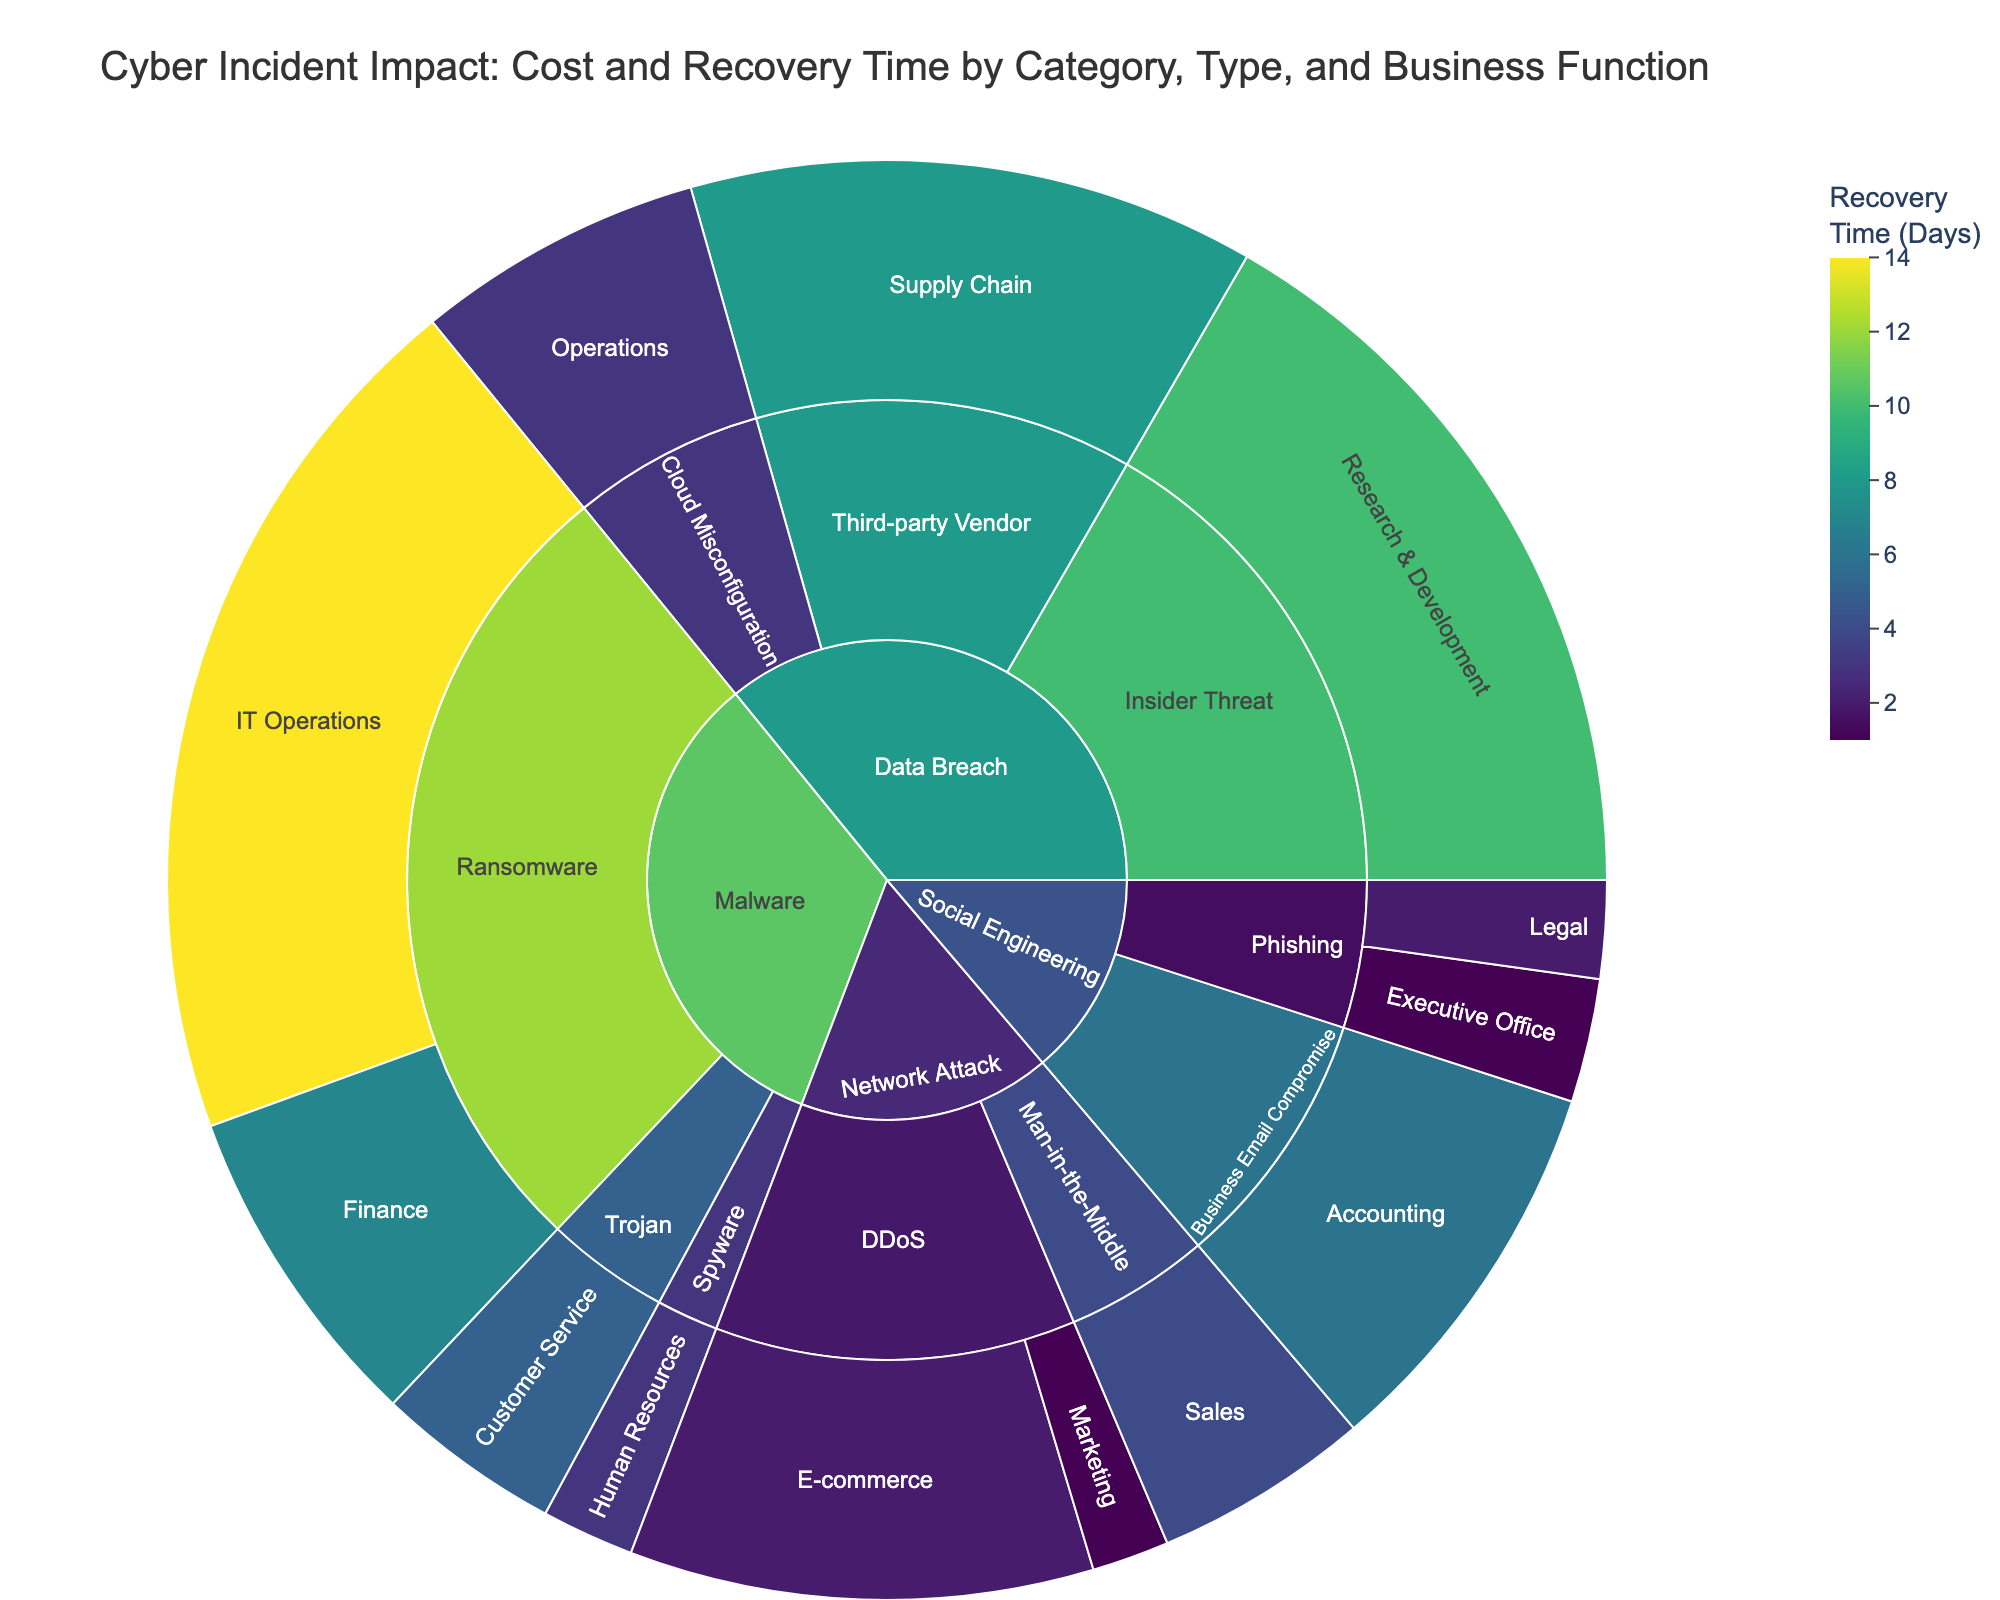What is the title of the Sunburst Plot? The title is prominently displayed at the top of the plot, and it is critical for understanding the focus of the visualization.
Answer: Cyber Incident Impact: Cost and Recovery Time by Category, Type, and Business Function How many different categories of cyber incidents are represented in the plot? The outermost segment of the Sunburst Plot represents different categories. Count the unique segments.
Answer: 4 Which incident type in the 'Malware' category has the highest recovery cost? Navigate to the 'Malware' category and then compare the recovery costs of different incident types within it.
Answer: Ransomware What is the recovery time for Phishing incidents in the Executive Office function? Locate the 'Social Engineering' category, then find 'Phishing' and navigate to the 'Executive Office' function to read the recovery time.
Answer: 1 day What is the total recovery time for all incident types in the 'Network Attack' category? Add the recovery times for 'DDoS' (2 + 1 days) and 'Man-in-the-Middle' (4 days) under 'Network Attack'.
Answer: 7 days Which business function under the 'Data Breach' category has the highest cost and what is the cost? Navigate from 'Data Breach' to each business function, comparing costs. The highest cost will be in the segment that extends the farthest from the center.
Answer: Supply Chain, $550K Compare the recovery time between 'Business Email Compromise' in Accounting and 'Ransomware' in IT Operations. Which one is greater and by how much? Find both segments and compare their recovery times; subtract the smaller from the larger.
Answer: 'Ransomware' in IT Operations is greater by 8 days (14 - 6) What is the average recovery time for 'Data Breach' incidents? Add up the recovery times for each incident type in 'Data Breach' (10 + 3 + 8 days) and divide by the number of incidents (3).
Answer: 7 days What business functions are affected by DDoS attacks and what are their associated recovery costs? Locate the 'Network Attack' category, then find 'DDoS'. List the business functions under 'DDoS' along with their recovery costs.
Answer: E-commerce $450K, Marketing $75K 